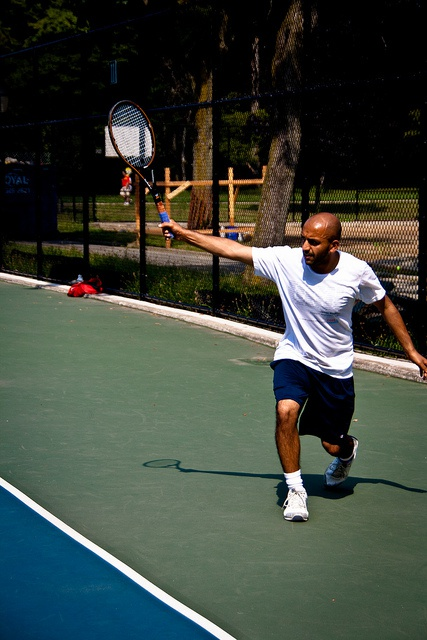Describe the objects in this image and their specific colors. I can see people in black, white, gray, and maroon tones, tennis racket in black, lightgray, darkgray, and gray tones, backpack in black, red, brown, and maroon tones, and people in black, maroon, olive, and red tones in this image. 